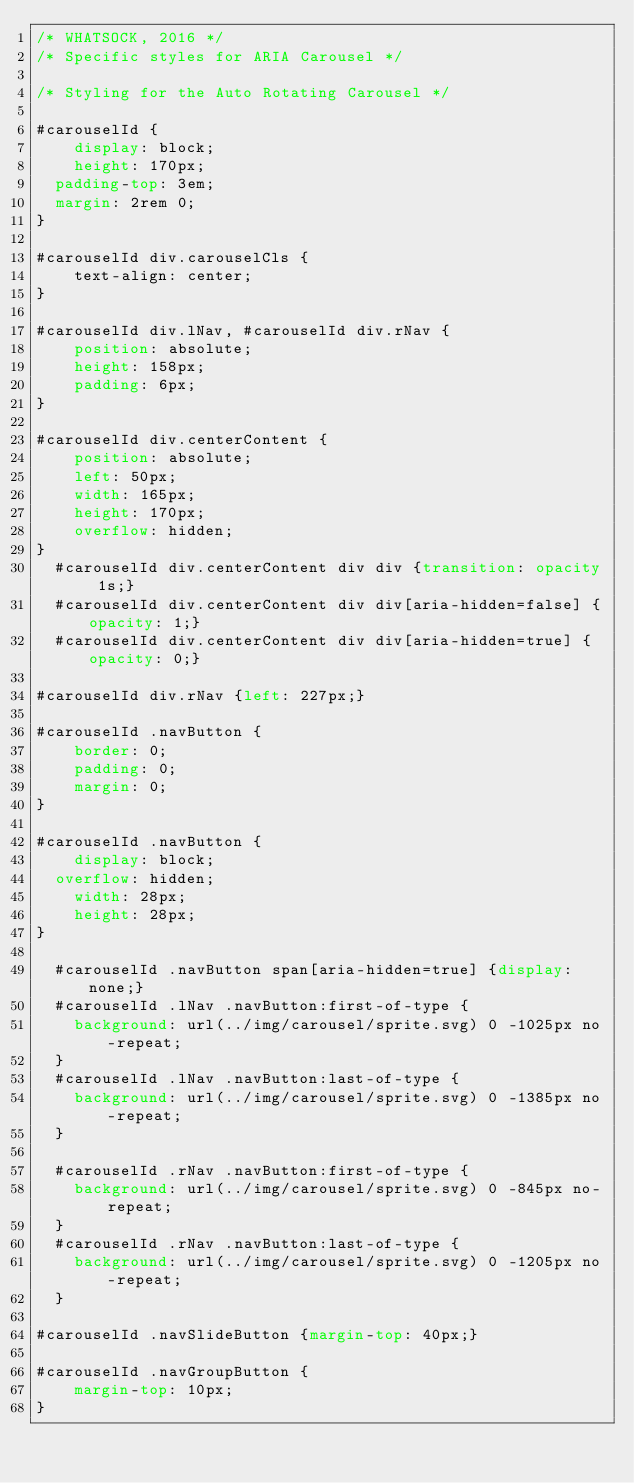Convert code to text. <code><loc_0><loc_0><loc_500><loc_500><_CSS_>/* WHATSOCK, 2016 */
/* Specific styles for ARIA Carousel */

/* Styling for the Auto Rotating Carousel */

#carouselId {
    display: block;
    height: 170px;
	padding-top: 3em;
	margin: 2rem 0;
}

#carouselId div.carouselCls {
    text-align: center;
}

#carouselId div.lNav, #carouselId div.rNav {
    position: absolute;
    height: 158px;
    padding: 6px;
}

#carouselId div.centerContent {
    position: absolute;
    left: 50px;
    width: 165px;
    height: 170px;
    overflow: hidden;
}
	#carouselId div.centerContent div div {transition: opacity 1s;}
	#carouselId div.centerContent div div[aria-hidden=false] {opacity: 1;}
	#carouselId div.centerContent div div[aria-hidden=true] {opacity: 0;}

#carouselId div.rNav {left: 227px;}

#carouselId .navButton {
    border: 0;
    padding: 0;
    margin: 0;
}

#carouselId .navButton {
    display: block;
	overflow: hidden;
    width: 28px;
    height: 28px;
}

	#carouselId .navButton span[aria-hidden=true] {display: none;}
	#carouselId .lNav .navButton:first-of-type {
		background: url(../img/carousel/sprite.svg) 0 -1025px no-repeat;
	}
	#carouselId .lNav .navButton:last-of-type {
		background: url(../img/carousel/sprite.svg) 0 -1385px no-repeat;
	}
	
	#carouselId .rNav .navButton:first-of-type {
		background: url(../img/carousel/sprite.svg) 0 -845px no-repeat;
	}
	#carouselId .rNav .navButton:last-of-type {
		background: url(../img/carousel/sprite.svg) 0 -1205px no-repeat;
	}

#carouselId .navSlideButton {margin-top: 40px;}

#carouselId .navGroupButton {
    margin-top: 10px;
}
</code> 